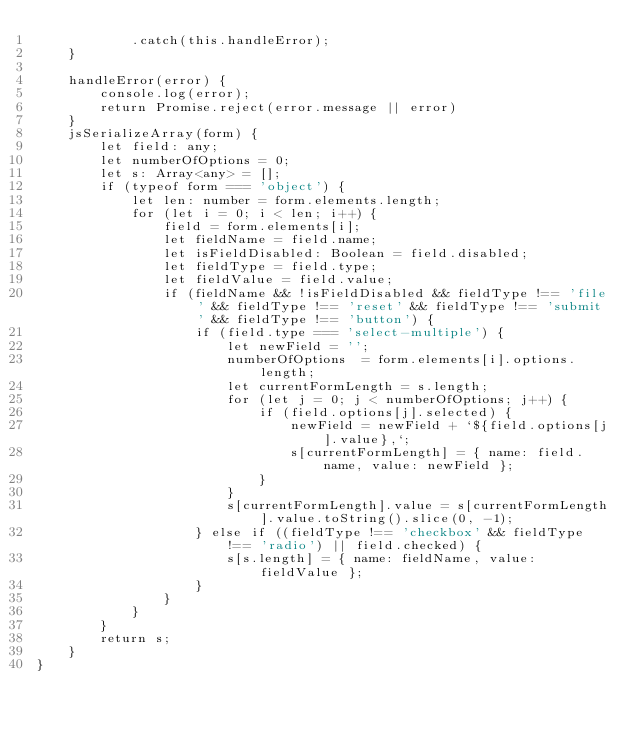<code> <loc_0><loc_0><loc_500><loc_500><_TypeScript_>			.catch(this.handleError);
	}

	handleError(error) {
		console.log(error);
		return Promise.reject(error.message || error)
	}
	jsSerializeArray(form) {
		let field: any;
		let numberOfOptions = 0;
		let s: Array<any> = [];
		if (typeof form === 'object') {
			let len: number = form.elements.length;
			for (let i = 0; i < len; i++) {
				field = form.elements[i];
				let fieldName = field.name;
				let isFieldDisabled: Boolean = field.disabled;
				let fieldType = field.type;
				let fieldValue = field.value;
				if (fieldName && !isFieldDisabled && fieldType !== 'file' && fieldType !== 'reset' && fieldType !== 'submit' && fieldType !== 'button') {
					if (field.type === 'select-multiple') {
						let newField = '';
						numberOfOptions  = form.elements[i].options.length;
						let currentFormLength = s.length;
						for (let j = 0; j < numberOfOptions; j++) {
							if (field.options[j].selected) {
								newField = newField + `${field.options[j].value},`;
								s[currentFormLength] = { name: field.name, value: newField };
							}
						}
						s[currentFormLength].value = s[currentFormLength].value.toString().slice(0, -1);
					} else if ((fieldType !== 'checkbox' && fieldType !== 'radio') || field.checked) {
						s[s.length] = { name: fieldName, value: fieldValue };
					}
				}
			}
		}
		return s;
	}
}</code> 